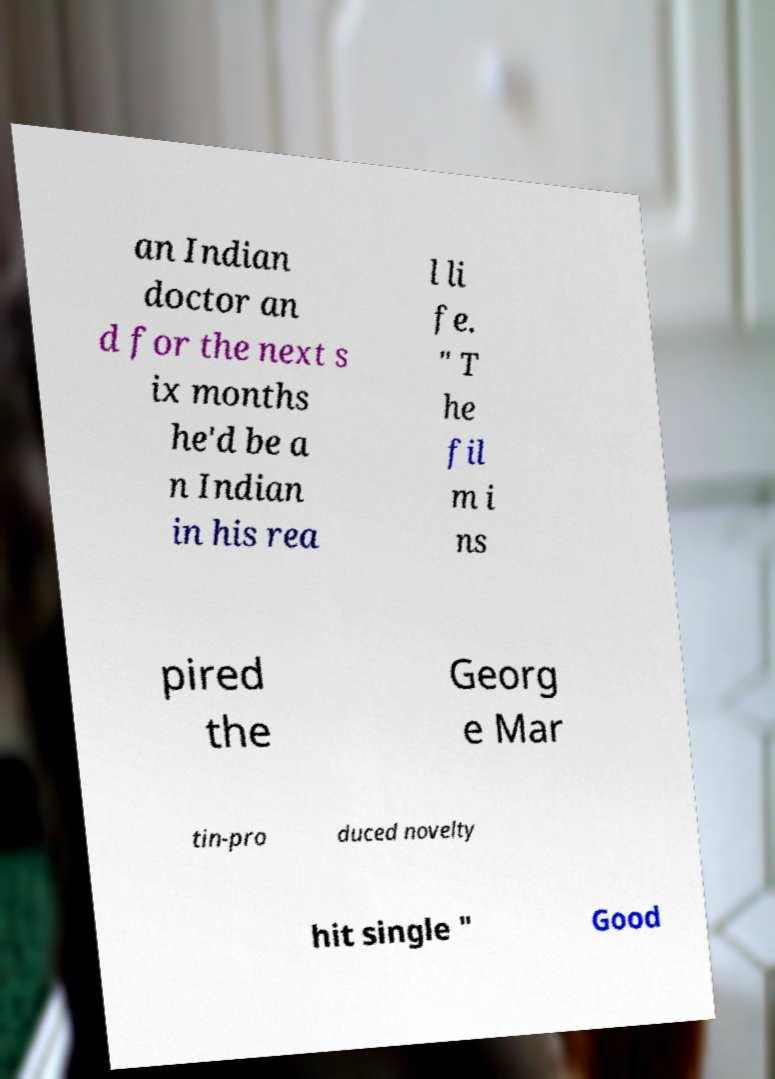I need the written content from this picture converted into text. Can you do that? an Indian doctor an d for the next s ix months he'd be a n Indian in his rea l li fe. " T he fil m i ns pired the Georg e Mar tin-pro duced novelty hit single " Good 